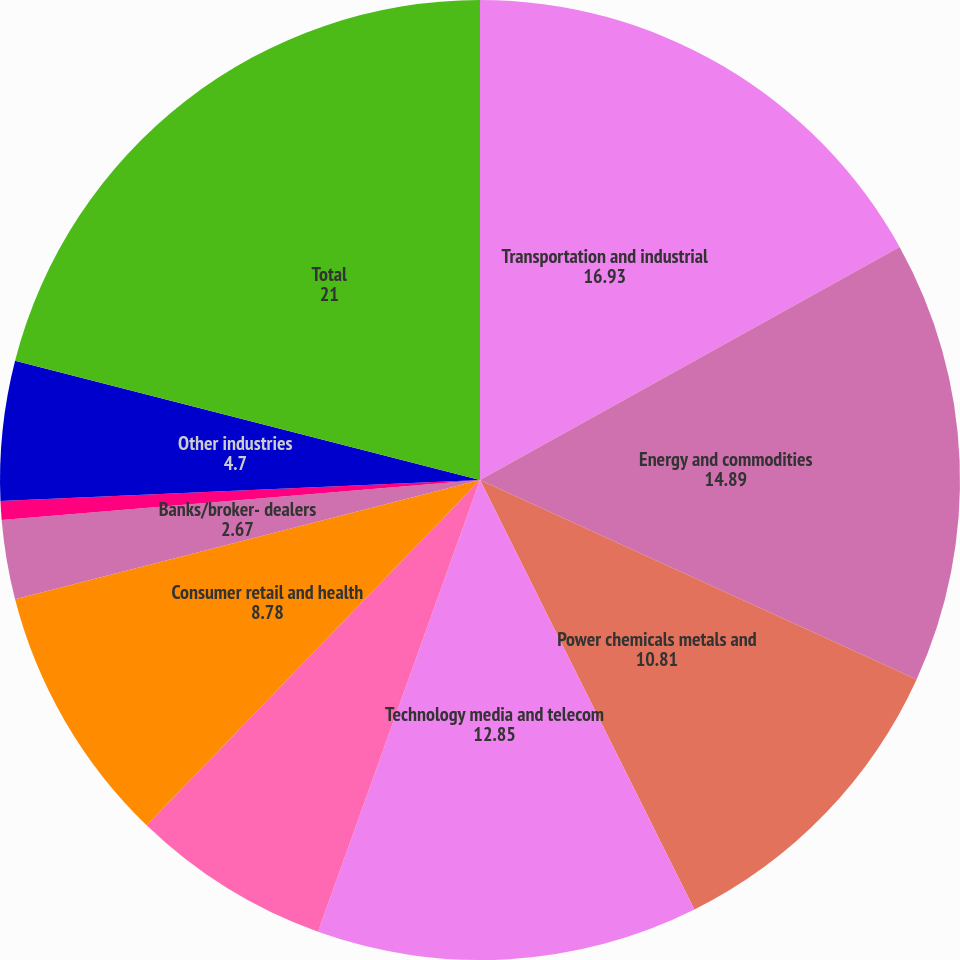<chart> <loc_0><loc_0><loc_500><loc_500><pie_chart><fcel>Transportation and industrial<fcel>Energy and commodities<fcel>Power chemicals metals and<fcel>Technology media and telecom<fcel>Public sector<fcel>Consumer retail and health<fcel>Banks/broker- dealers<fcel>Insurance and special purpose<fcel>Other industries<fcel>Total<nl><fcel>16.93%<fcel>14.89%<fcel>10.81%<fcel>12.85%<fcel>6.74%<fcel>8.78%<fcel>2.67%<fcel>0.63%<fcel>4.7%<fcel>21.0%<nl></chart> 